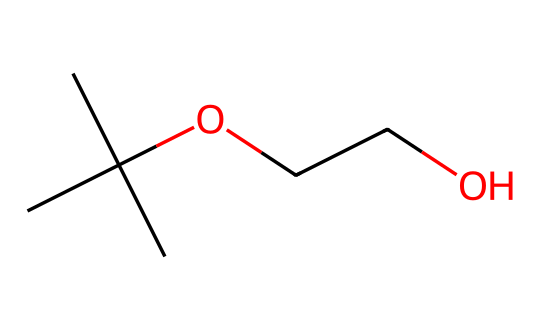What is the total number of carbon atoms in the structure? The SMILES representation indicates there are three carbon atoms in the isopropyl group (CC(C)) and two additional carbon atoms in the two ethyl groups (from the OCC part). Summing these gives a total of five carbon atoms.
Answer: five How many oxygen atoms are present in the chemical? The SMILES representation contains two oxygen atoms indicated by the 'O' in the structure (from 'CC(C)OCCO'). Therefore, the total number of oxygen atoms is two.
Answer: two What is the primary functional group in this chemical? The presence of an 'O' between carbon atoms in the chain indicates that this chemical has ether characteristics, suggesting the primary functional group is ether.
Answer: ether Does this chemical belong to the category of Non-Newtonian fluids? Given that the chemical has a structured yet flexible chain and fits typical properties of Non-Newtonian fluids (such as varying viscosity under stress), it can be categorized as such.
Answer: yes What effect does this molecular composition have on the viscosity behavior? The branching of carbon atoms and presence of ether oxygen introduces both flexibility and intermolecular interactions, which can lead to shear-thinning behavior, a characteristic of Non-Newtonian fluids which decreases viscosity under stress.
Answer: shear-thinning Which part of the structure contributes to its fluid preservation capabilities? The ether linkages in this chemical enhance stability and preservation qualities due to their ability to form less aggressive interactions with polar solvents, making it suitable for film preservation fluids.
Answer: ether linkages 